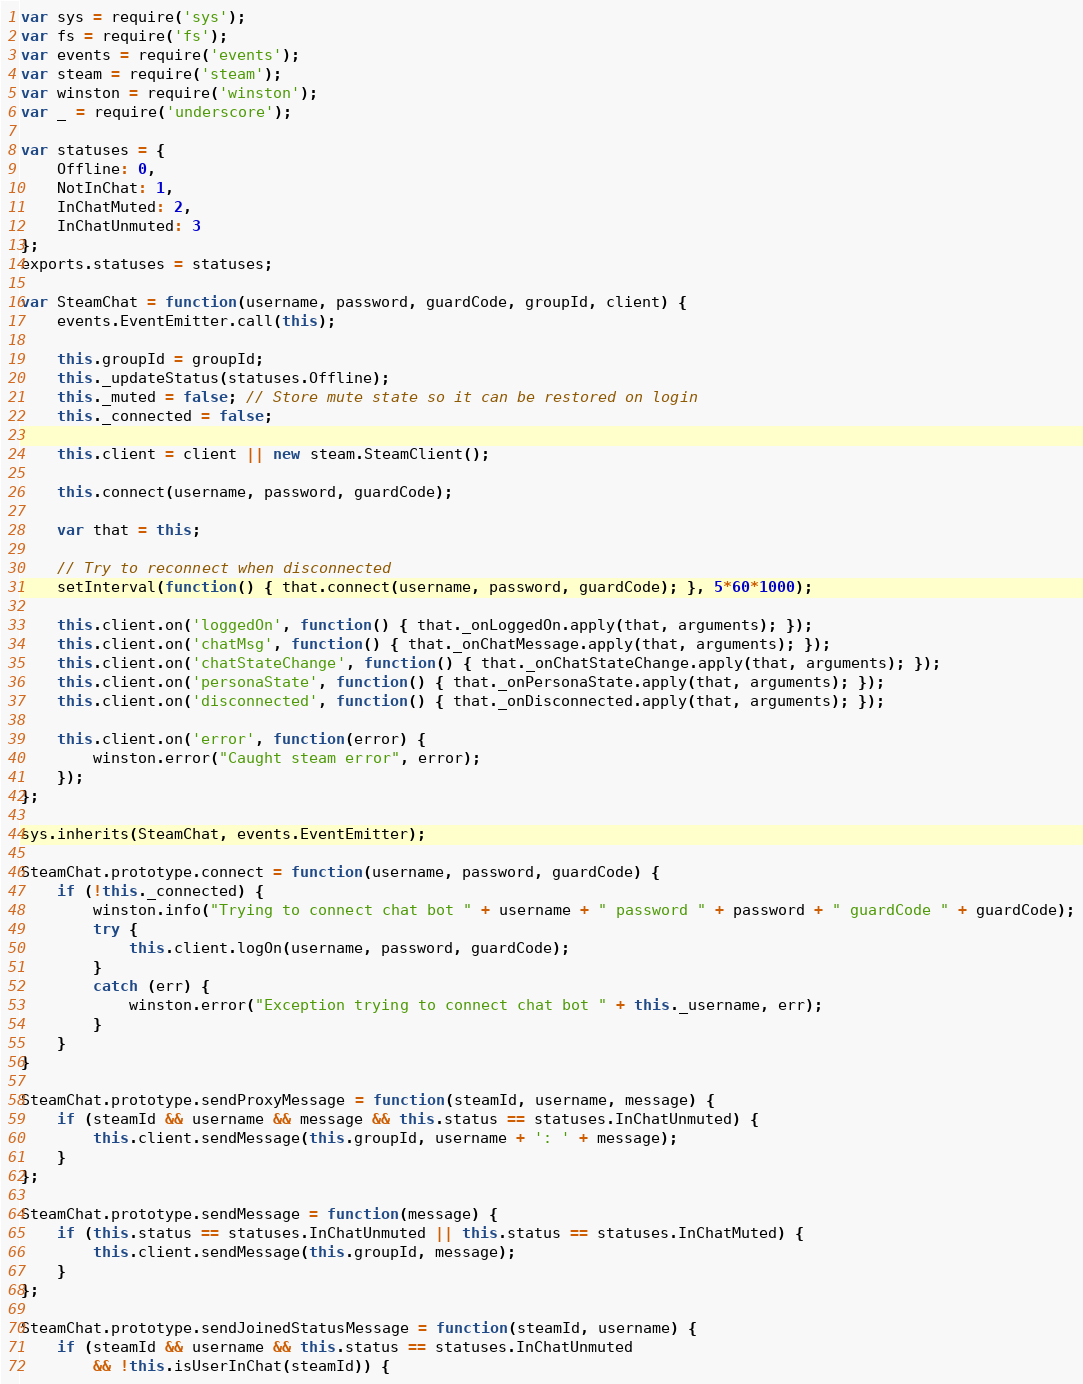<code> <loc_0><loc_0><loc_500><loc_500><_JavaScript_>var sys = require('sys');
var fs = require('fs');
var events = require('events');
var steam = require('steam');
var winston = require('winston');
var _ = require('underscore');

var statuses = {
	Offline: 0,
	NotInChat: 1,
	InChatMuted: 2,
	InChatUnmuted: 3
};
exports.statuses = statuses;

var SteamChat = function(username, password, guardCode, groupId, client) {
	events.EventEmitter.call(this);

	this.groupId = groupId;
	this._updateStatus(statuses.Offline);
	this._muted = false; // Store mute state so it can be restored on login
	this._connected = false;

	this.client = client || new steam.SteamClient();

	this.connect(username, password, guardCode);

	var that = this;

	// Try to reconnect when disconnected
	setInterval(function() { that.connect(username, password, guardCode); }, 5*60*1000);

	this.client.on('loggedOn', function() { that._onLoggedOn.apply(that, arguments); });
	this.client.on('chatMsg', function() { that._onChatMessage.apply(that, arguments); });
	this.client.on('chatStateChange', function() { that._onChatStateChange.apply(that, arguments); });
	this.client.on('personaState', function() { that._onPersonaState.apply(that, arguments); });
	this.client.on('disconnected', function() { that._onDisconnected.apply(that, arguments); });
	
	this.client.on('error', function(error) { 
		winston.error("Caught steam error", error);
	});
};

sys.inherits(SteamChat, events.EventEmitter);

SteamChat.prototype.connect = function(username, password, guardCode) {
	if (!this._connected) {
		winston.info("Trying to connect chat bot " + username + " password " + password + " guardCode " + guardCode);
		try {
			this.client.logOn(username, password, guardCode);
		}
		catch (err) {
			winston.error("Exception trying to connect chat bot " + this._username, err);
		}
	}
}

SteamChat.prototype.sendProxyMessage = function(steamId, username, message) {
	if (steamId && username && message && this.status == statuses.InChatUnmuted) {
		this.client.sendMessage(this.groupId, username + ': ' + message);
	}
};

SteamChat.prototype.sendMessage = function(message) {
	if (this.status == statuses.InChatUnmuted || this.status == statuses.InChatMuted) {
		this.client.sendMessage(this.groupId, message);
	}
};

SteamChat.prototype.sendJoinedStatusMessage = function(steamId, username) {
	if (steamId && username && this.status == statuses.InChatUnmuted 
		&& !this.isUserInChat(steamId)) {
</code> 